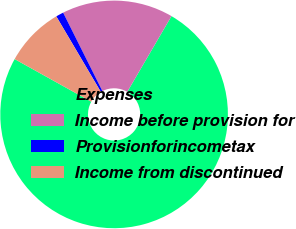Convert chart to OTSL. <chart><loc_0><loc_0><loc_500><loc_500><pie_chart><fcel>Expenses<fcel>Income before provision for<fcel>Provisionforincometax<fcel>Income from discontinued<nl><fcel>74.67%<fcel>15.8%<fcel>1.09%<fcel>8.44%<nl></chart> 